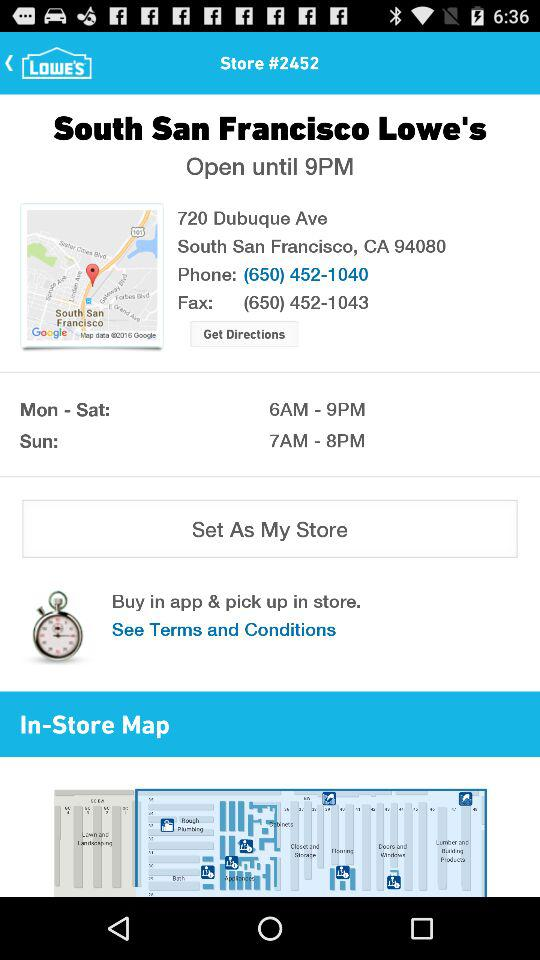What is the phone number? The phone number is (650) 452-1040. 